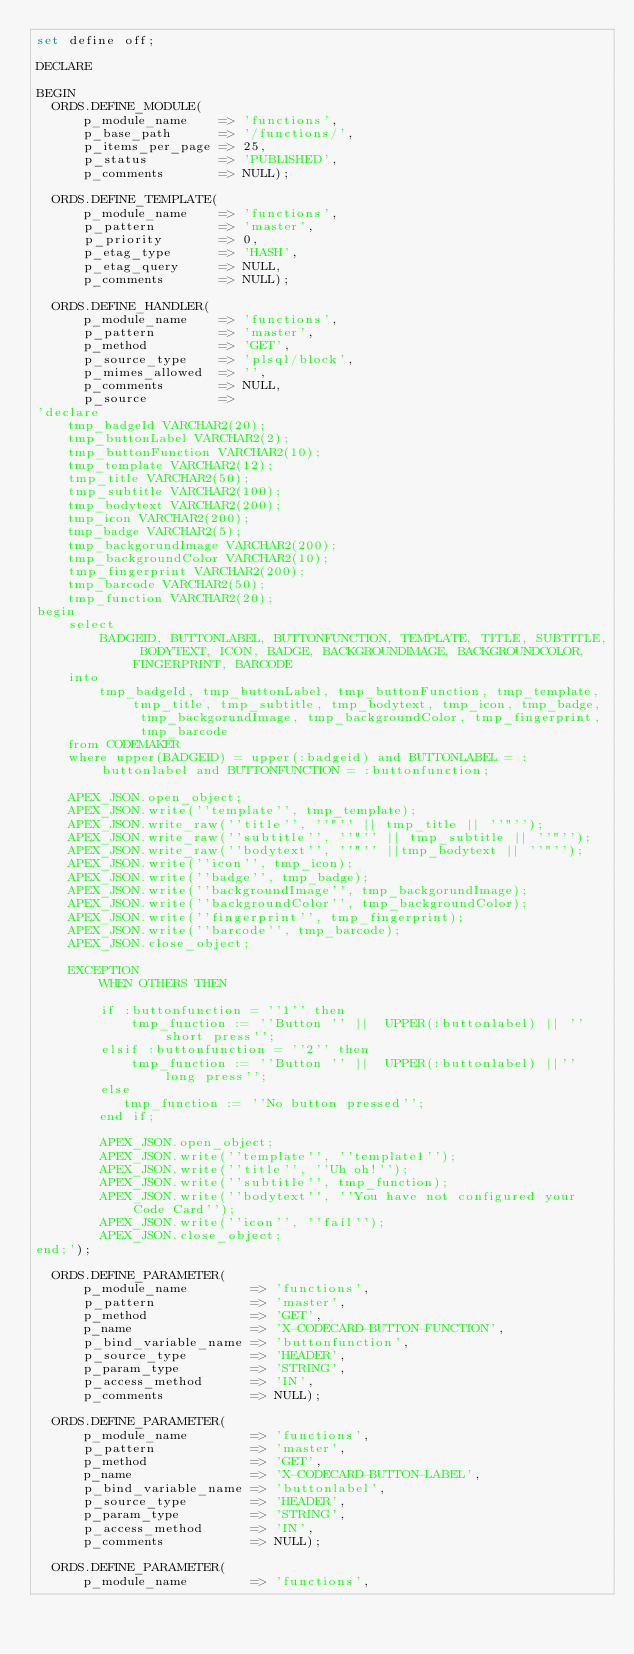<code> <loc_0><loc_0><loc_500><loc_500><_SQL_>set define off;

DECLARE

BEGIN
  ORDS.DEFINE_MODULE(
      p_module_name    => 'functions',
      p_base_path      => '/functions/',
      p_items_per_page => 25,
      p_status         => 'PUBLISHED',
      p_comments       => NULL);

  ORDS.DEFINE_TEMPLATE(
      p_module_name    => 'functions',
      p_pattern        => 'master',
      p_priority       => 0,
      p_etag_type      => 'HASH',
      p_etag_query     => NULL,
      p_comments       => NULL);

  ORDS.DEFINE_HANDLER(
      p_module_name    => 'functions',
      p_pattern        => 'master',
      p_method         => 'GET',
      p_source_type    => 'plsql/block',
      p_mimes_allowed  => '',
      p_comments       => NULL,
      p_source         => 
'declare
	tmp_badgeId VARCHAR2(20);
	tmp_buttonLabel VARCHAR2(2);
	tmp_buttonFunction VARCHAR2(10);
	tmp_template VARCHAR2(12);
	tmp_title VARCHAR2(50);
	tmp_subtitle VARCHAR2(100);
	tmp_bodytext VARCHAR2(200);
	tmp_icon VARCHAR2(200);
	tmp_badge VARCHAR2(5);
	tmp_backgorundImage VARCHAR2(200);
	tmp_backgroundColor VARCHAR2(10);
    tmp_fingerprint VARCHAR2(200);
	tmp_barcode VARCHAR2(50);
    tmp_function VARCHAR2(20);
begin
    select
        BADGEID, BUTTONLABEL, BUTTONFUNCTION, TEMPLATE, TITLE, SUBTITLE, BODYTEXT, ICON, BADGE, BACKGROUNDIMAGE, BACKGROUNDCOLOR, FINGERPRINT, BARCODE
    into
        tmp_badgeId, tmp_buttonLabel, tmp_buttonFunction, tmp_template, tmp_title, tmp_subtitle, tmp_bodytext, tmp_icon, tmp_badge, tmp_backgorundImage, tmp_backgroundColor, tmp_fingerprint, tmp_barcode
    from CODEMAKER
    where upper(BADGEID) = upper(:badgeid) and BUTTONLABEL = :buttonlabel and BUTTONFUNCTION = :buttonfunction;
    
    APEX_JSON.open_object;
    APEX_JSON.write(''template'', tmp_template);
    APEX_JSON.write_raw(''title'', ''"'' || tmp_title || ''"'');
    APEX_JSON.write_raw(''subtitle'', ''"'' || tmp_subtitle || ''"'');
    APEX_JSON.write_raw(''bodytext'', ''"'' ||tmp_bodytext || ''"'');
    APEX_JSON.write(''icon'', tmp_icon);
    APEX_JSON.write(''badge'', tmp_badge);
    APEX_JSON.write(''backgroundImage'', tmp_backgorundImage);
    APEX_JSON.write(''backgroundColor'', tmp_backgroundColor);
    APEX_JSON.write(''fingerprint'', tmp_fingerprint);
    APEX_JSON.write(''barcode'', tmp_barcode);
    APEX_JSON.close_object;
    
    EXCEPTION
        WHEN OTHERS THEN
        
        if :buttonfunction = ''1'' then
            tmp_function := ''Button '' ||  UPPER(:buttonlabel) || '' short press'';
        elsif :buttonfunction = ''2'' then
            tmp_function := ''Button '' ||  UPPER(:buttonlabel) ||'' long press'';
        else
           tmp_function := ''No button pressed''; 
        end if;

        APEX_JSON.open_object;
        APEX_JSON.write(''template'', ''template1'');
        APEX_JSON.write(''title'', ''Uh oh!'');
        APEX_JSON.write(''subtitle'', tmp_function);
        APEX_JSON.write(''bodytext'', ''You have not configured your Code Card'');
        APEX_JSON.write(''icon'', ''fail'');
        APEX_JSON.close_object;        
end;');

  ORDS.DEFINE_PARAMETER(
      p_module_name        => 'functions',
      p_pattern            => 'master',
      p_method             => 'GET',
      p_name               => 'X-CODECARD-BUTTON-FUNCTION',
      p_bind_variable_name => 'buttonfunction',
      p_source_type        => 'HEADER',
      p_param_type         => 'STRING',
      p_access_method      => 'IN',
      p_comments           => NULL);

  ORDS.DEFINE_PARAMETER(
      p_module_name        => 'functions',
      p_pattern            => 'master',
      p_method             => 'GET',
      p_name               => 'X-CODECARD-BUTTON-LABEL',
      p_bind_variable_name => 'buttonlabel',
      p_source_type        => 'HEADER',
      p_param_type         => 'STRING',
      p_access_method      => 'IN',
      p_comments           => NULL);

  ORDS.DEFINE_PARAMETER(
      p_module_name        => 'functions',</code> 